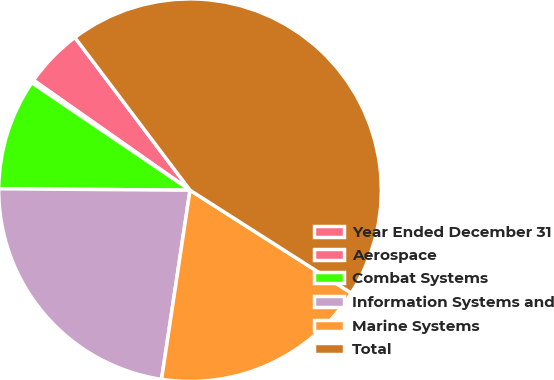Convert chart to OTSL. <chart><loc_0><loc_0><loc_500><loc_500><pie_chart><fcel>Year Ended December 31<fcel>Aerospace<fcel>Combat Systems<fcel>Information Systems and<fcel>Marine Systems<fcel>Total<nl><fcel>4.97%<fcel>0.26%<fcel>9.37%<fcel>22.74%<fcel>18.34%<fcel>44.32%<nl></chart> 